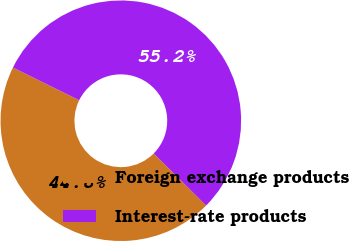Convert chart. <chart><loc_0><loc_0><loc_500><loc_500><pie_chart><fcel>Foreign exchange products<fcel>Interest-rate products<nl><fcel>44.83%<fcel>55.17%<nl></chart> 